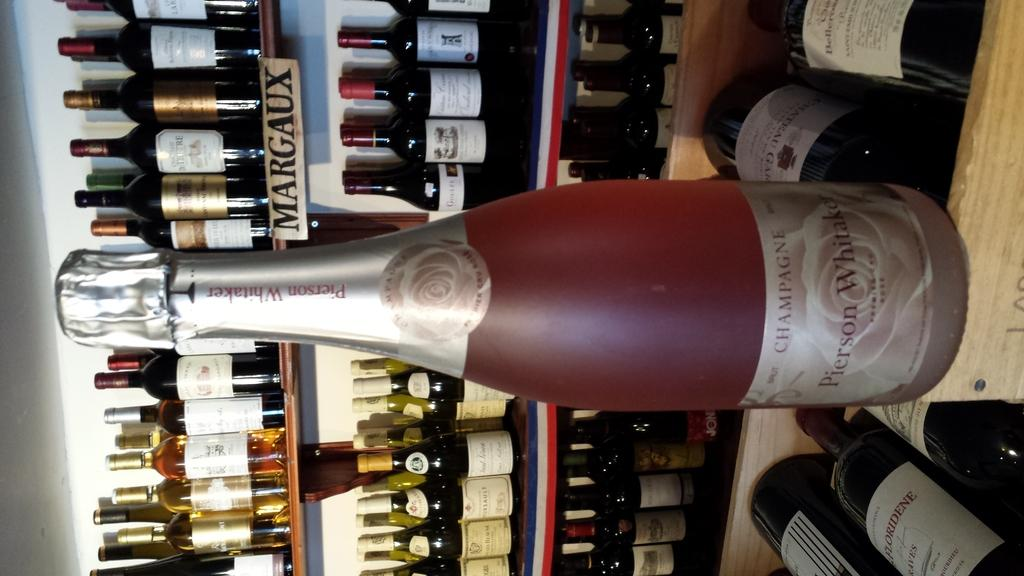<image>
Write a terse but informative summary of the picture. A pink bottle of champagne says "Pierson Whitaker" on the label. 